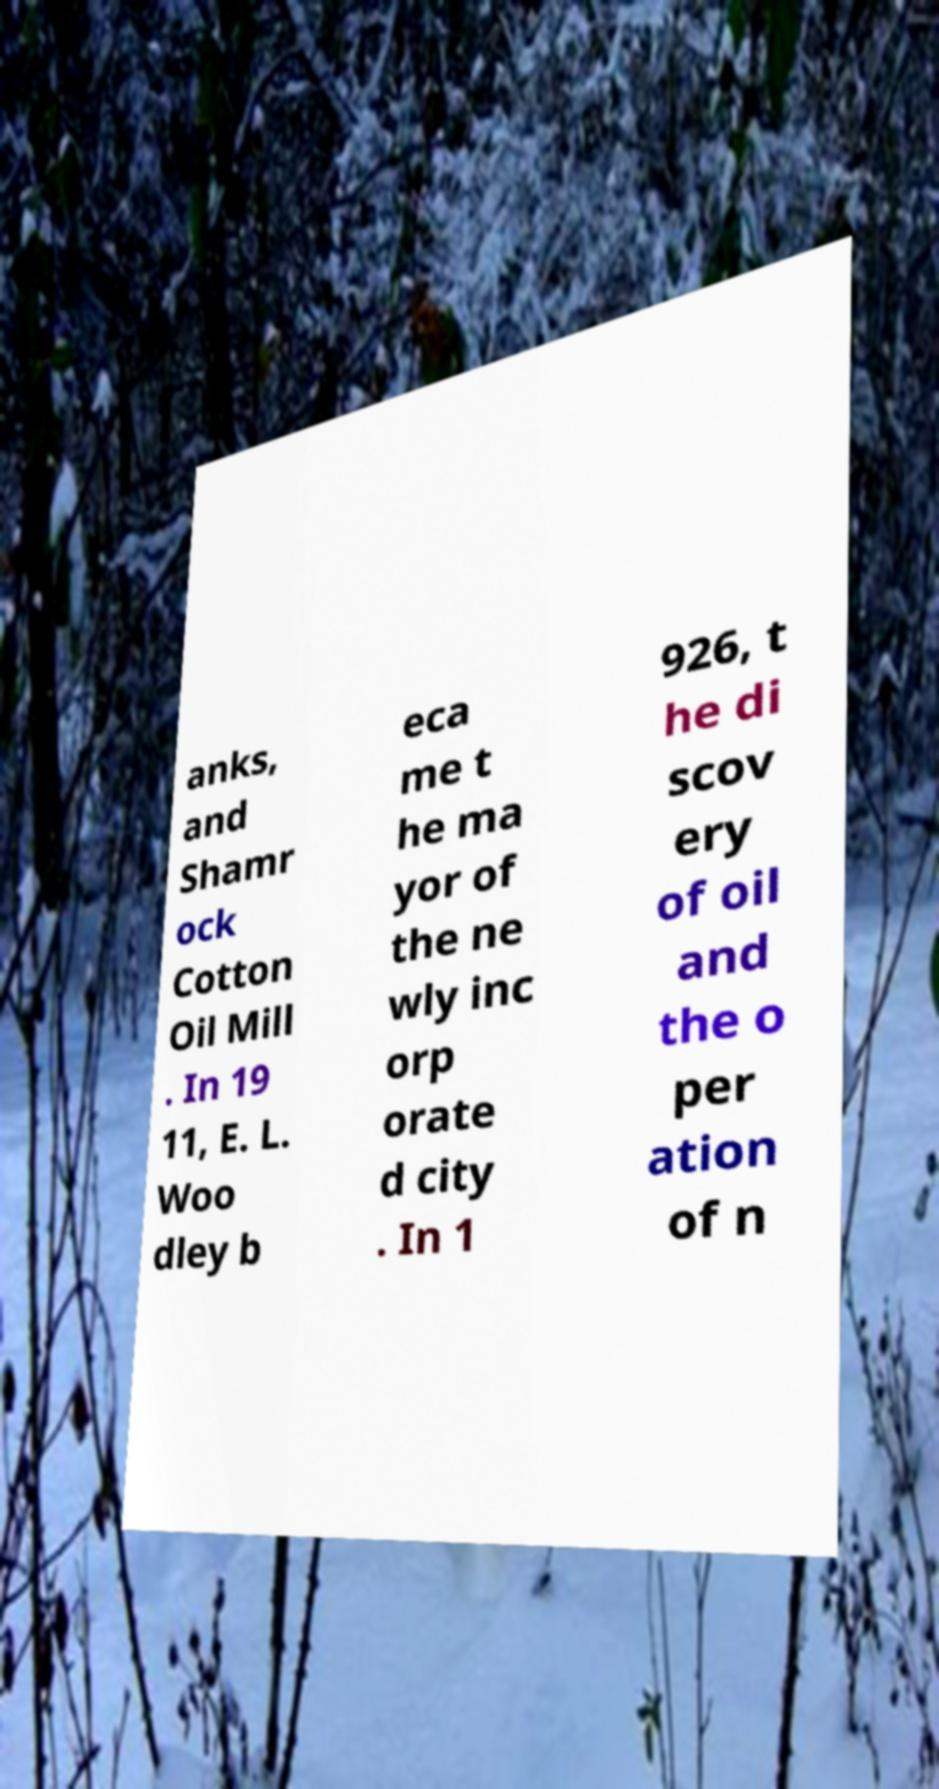For documentation purposes, I need the text within this image transcribed. Could you provide that? anks, and Shamr ock Cotton Oil Mill . In 19 11, E. L. Woo dley b eca me t he ma yor of the ne wly inc orp orate d city . In 1 926, t he di scov ery of oil and the o per ation of n 